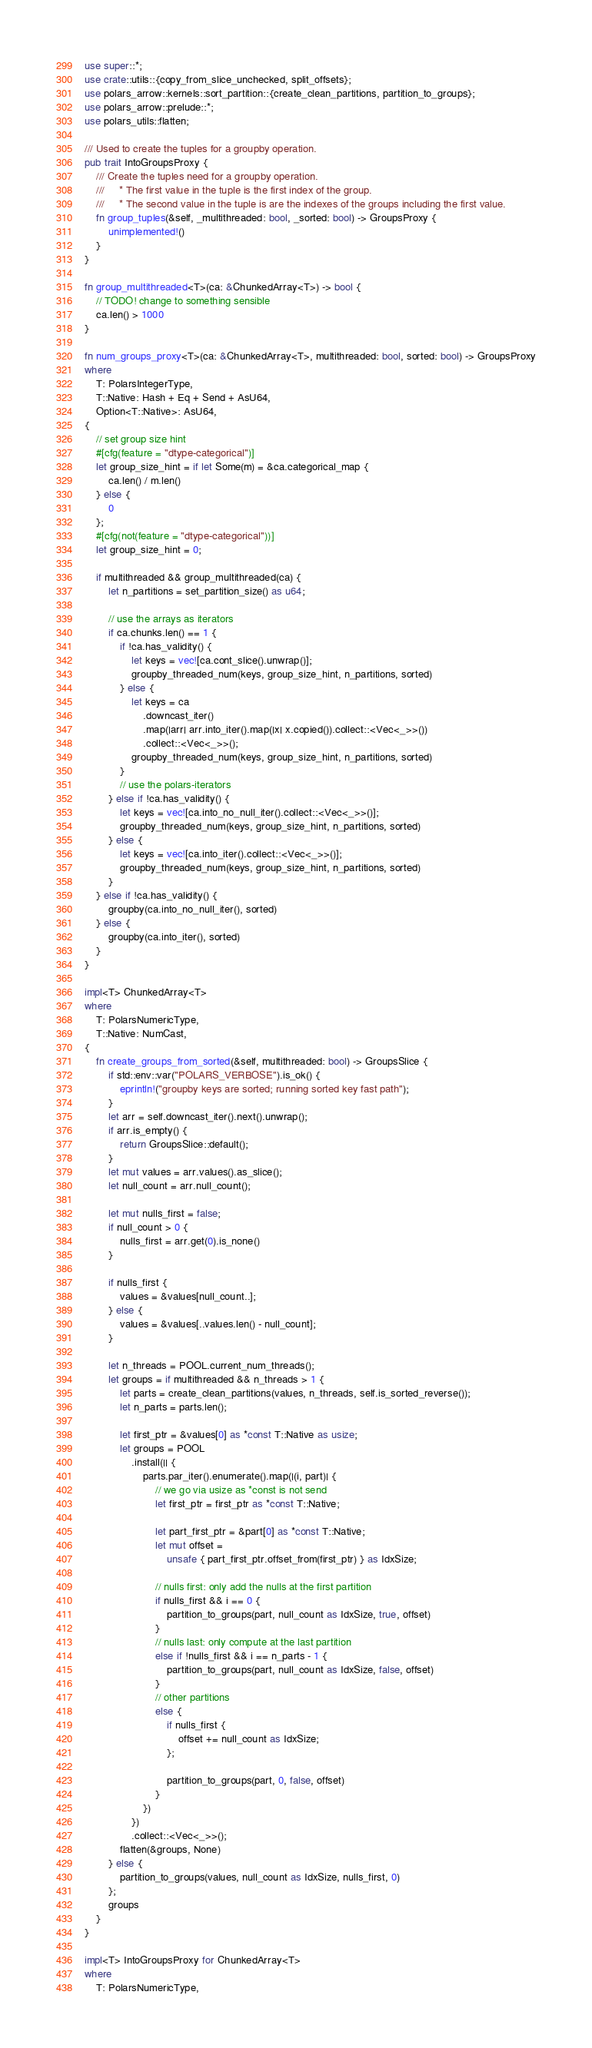Convert code to text. <code><loc_0><loc_0><loc_500><loc_500><_Rust_>use super::*;
use crate::utils::{copy_from_slice_unchecked, split_offsets};
use polars_arrow::kernels::sort_partition::{create_clean_partitions, partition_to_groups};
use polars_arrow::prelude::*;
use polars_utils::flatten;

/// Used to create the tuples for a groupby operation.
pub trait IntoGroupsProxy {
    /// Create the tuples need for a groupby operation.
    ///     * The first value in the tuple is the first index of the group.
    ///     * The second value in the tuple is are the indexes of the groups including the first value.
    fn group_tuples(&self, _multithreaded: bool, _sorted: bool) -> GroupsProxy {
        unimplemented!()
    }
}

fn group_multithreaded<T>(ca: &ChunkedArray<T>) -> bool {
    // TODO! change to something sensible
    ca.len() > 1000
}

fn num_groups_proxy<T>(ca: &ChunkedArray<T>, multithreaded: bool, sorted: bool) -> GroupsProxy
where
    T: PolarsIntegerType,
    T::Native: Hash + Eq + Send + AsU64,
    Option<T::Native>: AsU64,
{
    // set group size hint
    #[cfg(feature = "dtype-categorical")]
    let group_size_hint = if let Some(m) = &ca.categorical_map {
        ca.len() / m.len()
    } else {
        0
    };
    #[cfg(not(feature = "dtype-categorical"))]
    let group_size_hint = 0;

    if multithreaded && group_multithreaded(ca) {
        let n_partitions = set_partition_size() as u64;

        // use the arrays as iterators
        if ca.chunks.len() == 1 {
            if !ca.has_validity() {
                let keys = vec![ca.cont_slice().unwrap()];
                groupby_threaded_num(keys, group_size_hint, n_partitions, sorted)
            } else {
                let keys = ca
                    .downcast_iter()
                    .map(|arr| arr.into_iter().map(|x| x.copied()).collect::<Vec<_>>())
                    .collect::<Vec<_>>();
                groupby_threaded_num(keys, group_size_hint, n_partitions, sorted)
            }
            // use the polars-iterators
        } else if !ca.has_validity() {
            let keys = vec![ca.into_no_null_iter().collect::<Vec<_>>()];
            groupby_threaded_num(keys, group_size_hint, n_partitions, sorted)
        } else {
            let keys = vec![ca.into_iter().collect::<Vec<_>>()];
            groupby_threaded_num(keys, group_size_hint, n_partitions, sorted)
        }
    } else if !ca.has_validity() {
        groupby(ca.into_no_null_iter(), sorted)
    } else {
        groupby(ca.into_iter(), sorted)
    }
}

impl<T> ChunkedArray<T>
where
    T: PolarsNumericType,
    T::Native: NumCast,
{
    fn create_groups_from_sorted(&self, multithreaded: bool) -> GroupsSlice {
        if std::env::var("POLARS_VERBOSE").is_ok() {
            eprintln!("groupby keys are sorted; running sorted key fast path");
        }
        let arr = self.downcast_iter().next().unwrap();
        if arr.is_empty() {
            return GroupsSlice::default();
        }
        let mut values = arr.values().as_slice();
        let null_count = arr.null_count();

        let mut nulls_first = false;
        if null_count > 0 {
            nulls_first = arr.get(0).is_none()
        }

        if nulls_first {
            values = &values[null_count..];
        } else {
            values = &values[..values.len() - null_count];
        }

        let n_threads = POOL.current_num_threads();
        let groups = if multithreaded && n_threads > 1 {
            let parts = create_clean_partitions(values, n_threads, self.is_sorted_reverse());
            let n_parts = parts.len();

            let first_ptr = &values[0] as *const T::Native as usize;
            let groups = POOL
                .install(|| {
                    parts.par_iter().enumerate().map(|(i, part)| {
                        // we go via usize as *const is not send
                        let first_ptr = first_ptr as *const T::Native;

                        let part_first_ptr = &part[0] as *const T::Native;
                        let mut offset =
                            unsafe { part_first_ptr.offset_from(first_ptr) } as IdxSize;

                        // nulls first: only add the nulls at the first partition
                        if nulls_first && i == 0 {
                            partition_to_groups(part, null_count as IdxSize, true, offset)
                        }
                        // nulls last: only compute at the last partition
                        else if !nulls_first && i == n_parts - 1 {
                            partition_to_groups(part, null_count as IdxSize, false, offset)
                        }
                        // other partitions
                        else {
                            if nulls_first {
                                offset += null_count as IdxSize;
                            };

                            partition_to_groups(part, 0, false, offset)
                        }
                    })
                })
                .collect::<Vec<_>>();
            flatten(&groups, None)
        } else {
            partition_to_groups(values, null_count as IdxSize, nulls_first, 0)
        };
        groups
    }
}

impl<T> IntoGroupsProxy for ChunkedArray<T>
where
    T: PolarsNumericType,</code> 